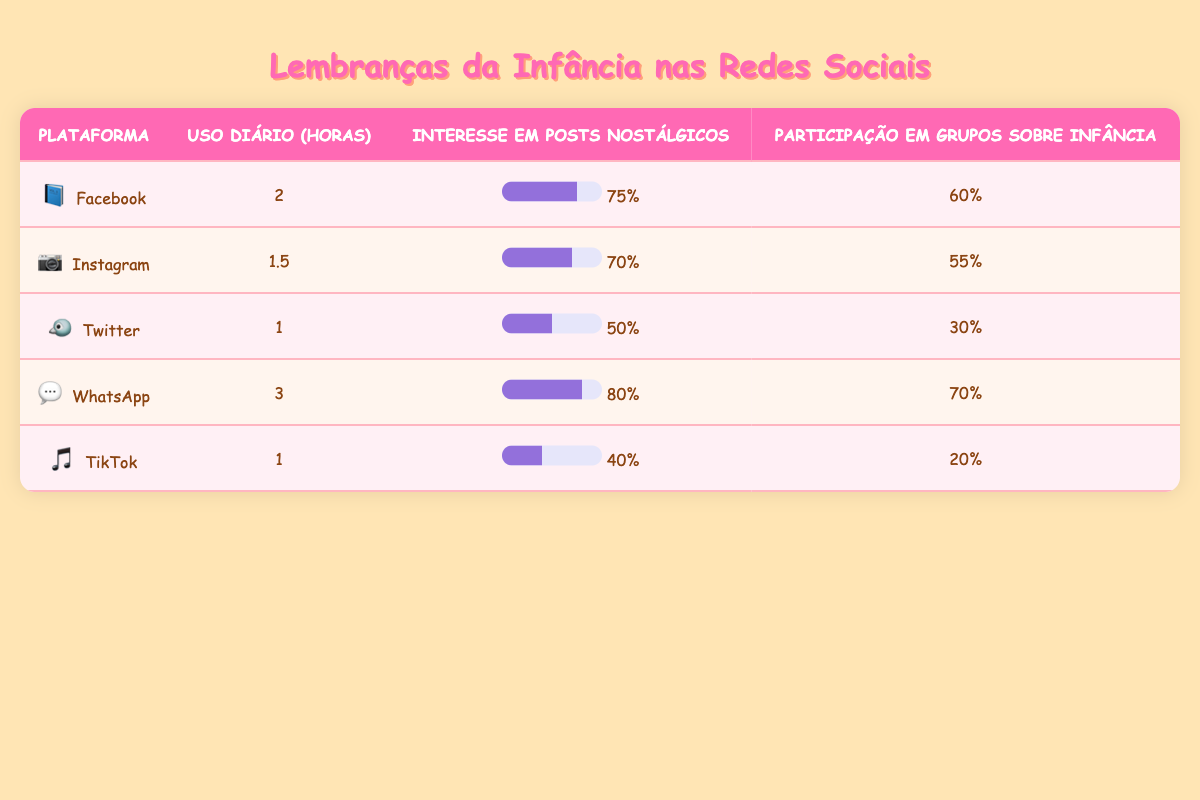What's the daily usage of WhatsApp in hours? The table lists the daily usage of WhatsApp as 3 hours.
Answer: 3 What percentage of users on Instagram are interested in nostalgic posts? According to the table, 70% of users on Instagram show interest in nostalgic posts.
Answer: 70% Is the interest in nostalgic posts higher on Facebook or TikTok? Facebook has an interest percentage of 75%, while TikTok has 40%. Therefore, Facebook's interest is higher.
Answer: Yes, Facebook What is the difference in daily usage hours between Facebook and Twitter? Facebook usage is 2 hours and Twitter is 1 hour, so the difference is 2 - 1 = 1 hour.
Answer: 1 hour What is the average interest in nostalgic posts across all platforms? To find the average, add the percentages: 75 + 70 + 50 + 80 + 40 = 315, then divide by 5 (number of platforms): 315 / 5 = 63.
Answer: 63 Which platform had the highest percentage of users participating in childhood-themed groups? WhatsApp had the highest participation at 70%.
Answer: WhatsApp Are users on TikTok more likely to participate in childhood-themed groups compared to those on Twitter? TikTok has 20% participation while Twitter has 30%, indicating that Twitter users are more likely to participate.
Answer: No What is the total percentage of interest in nostalgic posts from all platforms combined? Adding the percentages gives: 75 + 70 + 50 + 80 + 40 = 315.
Answer: 315 Which social media platform has the lowest daily usage? The platforms with the lowest daily usage are Twitter and TikTok, both at 1 hour.
Answer: Twitter and TikTok 